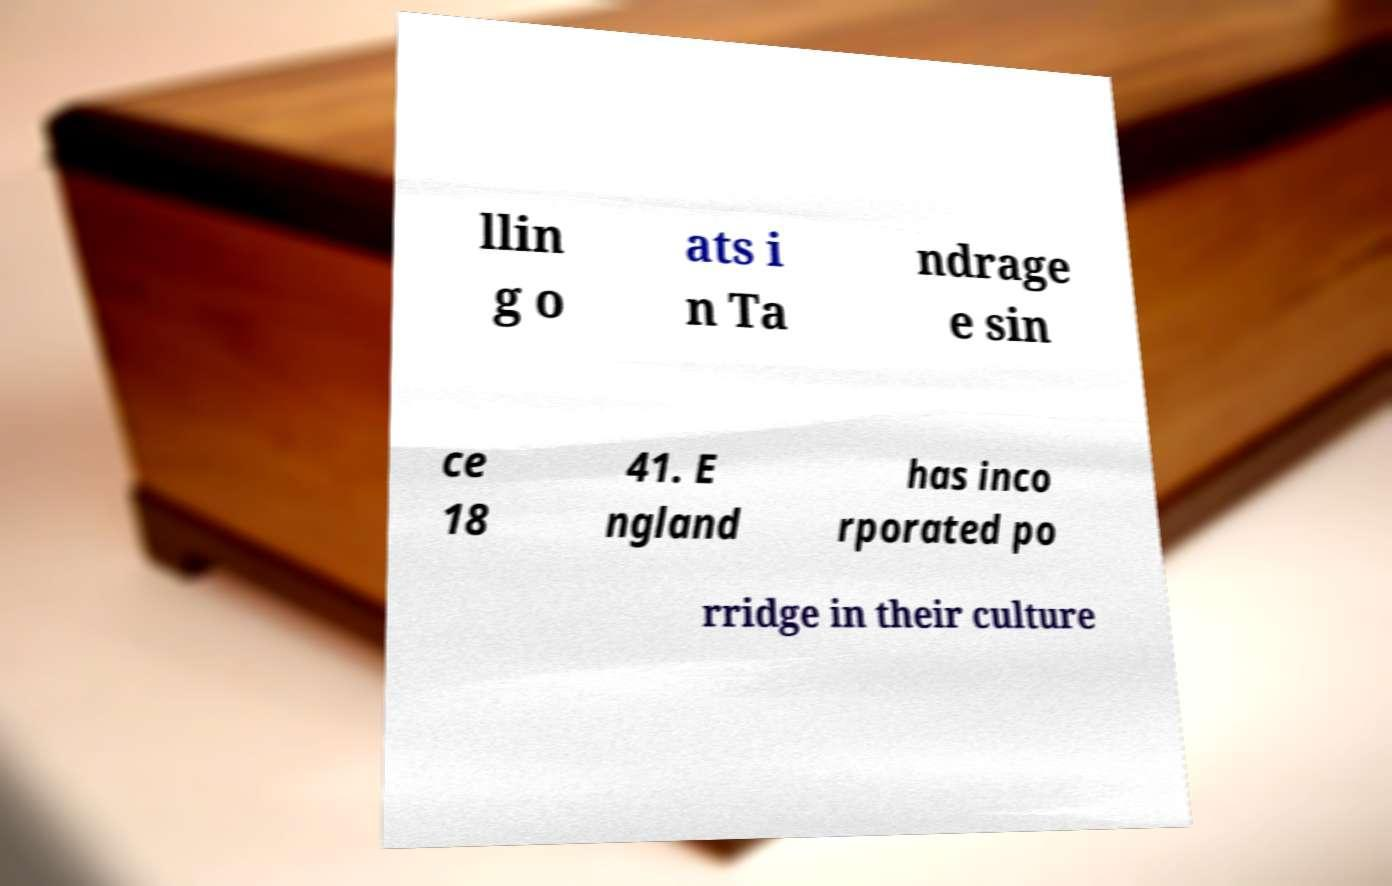Can you read and provide the text displayed in the image?This photo seems to have some interesting text. Can you extract and type it out for me? llin g o ats i n Ta ndrage e sin ce 18 41. E ngland has inco rporated po rridge in their culture 